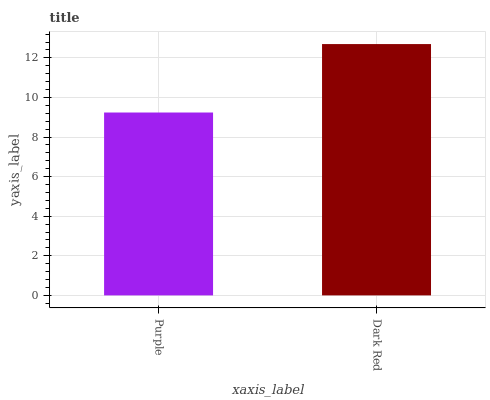Is Purple the minimum?
Answer yes or no. Yes. Is Dark Red the maximum?
Answer yes or no. Yes. Is Dark Red the minimum?
Answer yes or no. No. Is Dark Red greater than Purple?
Answer yes or no. Yes. Is Purple less than Dark Red?
Answer yes or no. Yes. Is Purple greater than Dark Red?
Answer yes or no. No. Is Dark Red less than Purple?
Answer yes or no. No. Is Dark Red the high median?
Answer yes or no. Yes. Is Purple the low median?
Answer yes or no. Yes. Is Purple the high median?
Answer yes or no. No. Is Dark Red the low median?
Answer yes or no. No. 